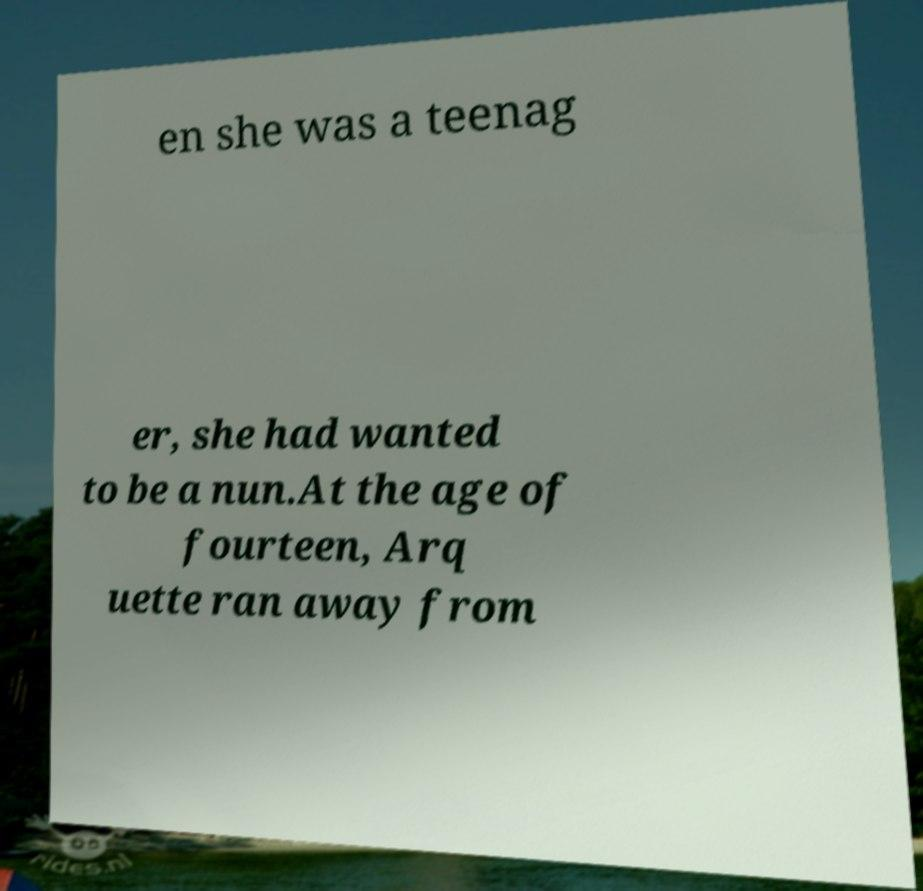Can you accurately transcribe the text from the provided image for me? en she was a teenag er, she had wanted to be a nun.At the age of fourteen, Arq uette ran away from 